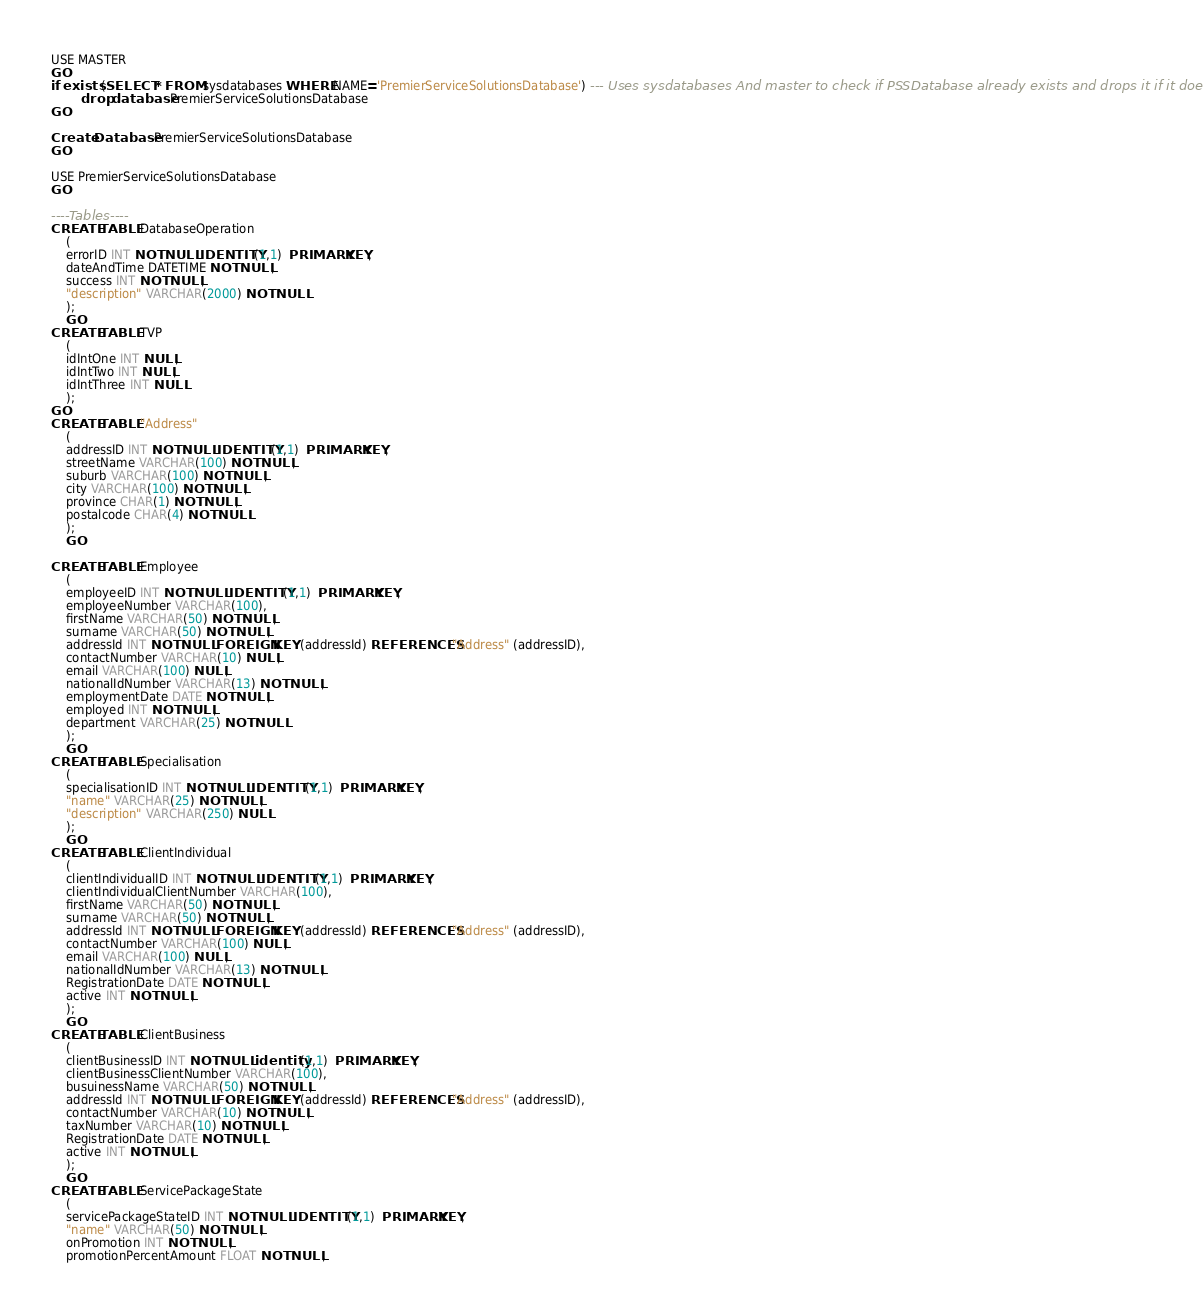<code> <loc_0><loc_0><loc_500><loc_500><_SQL_>USE MASTER
GO
if exists (SELECT * FROM sysdatabases WHERE NAME='PremierServiceSolutionsDatabase') --- Uses sysdatabases And master to check if PSSDatabase already exists and drops it if it does.
		drop database PremierServiceSolutionsDatabase
GO

Create Database PremierServiceSolutionsDatabase
GO

USE PremierServiceSolutionsDatabase
GO

----Tables----
CREATE TABLE DatabaseOperation
	(
	errorID INT NOT NULL IDENTITY(1,1)  PRIMARY KEY,
	dateAndTime DATETIME NOT NULL,
	success INT NOT NULL,
	"description" VARCHAR(2000) NOT NULL
	);
	GO
CREATE TABLE TVP
	(
	idIntOne INT NULL,
	idIntTwo INT NULL,
	idIntThree INT NULL
	);
GO
CREATE TABLE "Address"
	(
	addressID INT NOT NULL IDENTITY(1,1)  PRIMARY KEY,
	streetName VARCHAR(100) NOT NULL,
	suburb VARCHAR(100) NOT NULL,
	city VARCHAR(100) NOT NULL,
	province CHAR(1) NOT NULL,
	postalcode CHAR(4) NOT NULL
	);
	GO

CREATE TABLE Employee
	(
	employeeID INT NOT NULL IDENTITY(1,1)  PRIMARY KEY,
	employeeNumber VARCHAR(100),
	firstName VARCHAR(50) NOT NULL,
	surname VARCHAR(50) NOT NULL,
	addressId INT NOT NULL FOREIGN KEY (addressId) REFERENCES "Address" (addressID),
	contactNumber VARCHAR(10) NULL,
	email VARCHAR(100) NULL,
	nationalIdNumber VARCHAR(13) NOT NULL,
	employmentDate DATE NOT NULL,
	employed INT NOT NULL,
	department VARCHAR(25) NOT NULL
	);
	GO
CREATE TABLE Specialisation
	(
	specialisationID INT NOT NULL IDENTITY(1,1)  PRIMARY KEY,
	"name" VARCHAR(25) NOT NULL,
	"description" VARCHAR(250) NULL
	);
	GO
CREATE TABLE ClientIndividual
	(
	clientIndividualID INT NOT NULL IDENTITY(1,1)  PRIMARY KEY,
	clientIndividualClientNumber VARCHAR(100),
	firstName VARCHAR(50) NOT NULL,
	surname VARCHAR(50) NOT NULL,
	addressId INT NOT NULL FOREIGN KEY (addressId) REFERENCES "Address" (addressID),
	contactNumber VARCHAR(100) NULL,
	email VARCHAR(100) NULL,
	nationalIdNumber VARCHAR(13) NOT NULL,
	RegistrationDate DATE NOT NULL,
	active INT NOT NULL,
	);
	GO
CREATE TABLE ClientBusiness
	(
	clientBusinessID INT NOT NULL identity(1,1)  PRIMARY KEY,
	clientBusinessClientNumber VARCHAR(100),
	busuinessName VARCHAR(50) NOT NULL,
	addressId INT NOT NULL FOREIGN KEY (addressId) REFERENCES "Address" (addressID),
	contactNumber VARCHAR(10) NOT NULL,
	taxNumber VARCHAR(10) NOT NULL,
	RegistrationDate DATE NOT NULL,
	active INT NOT NULL,
	);
	GO
CREATE TABLE ServicePackageState
	(
	servicePackageStateID INT NOT NULL IDENTITY(1,1)  PRIMARY KEY,
	"name" VARCHAR(50) NOT NULL,
	onPromotion INT NOT NULL,
	promotionPercentAmount FLOAT NOT NULL,</code> 